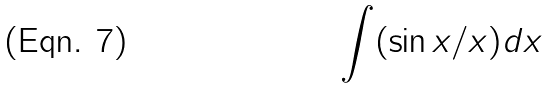Convert formula to latex. <formula><loc_0><loc_0><loc_500><loc_500>\int ( \sin x / x ) d x</formula> 